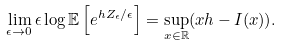<formula> <loc_0><loc_0><loc_500><loc_500>\lim _ { \epsilon \rightarrow 0 } \epsilon \log \mathbb { E } \left [ e ^ { h Z _ { \epsilon } / \epsilon } \right ] = \sup _ { x \in \mathbb { R } } ( x h - I ( x ) ) .</formula> 